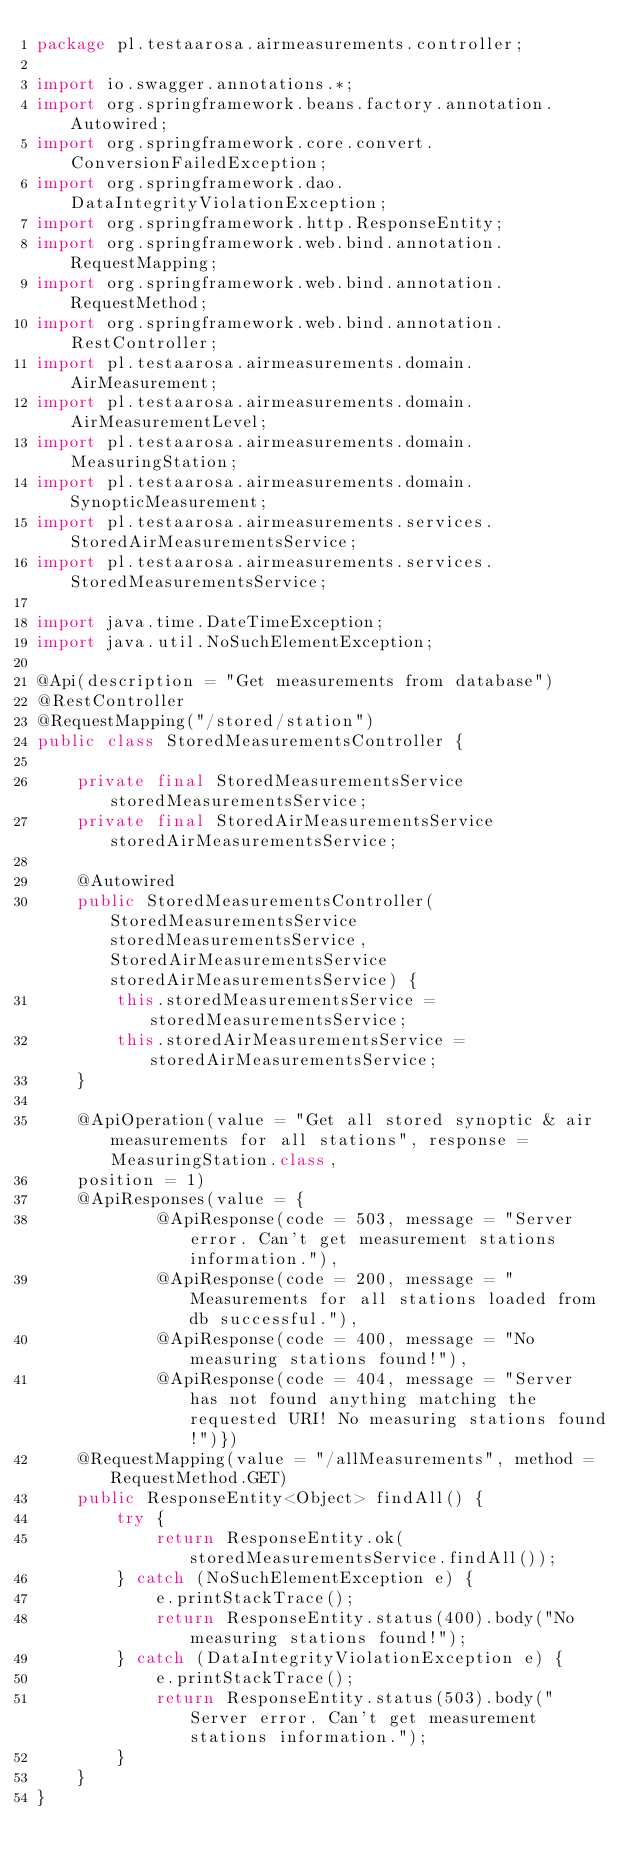<code> <loc_0><loc_0><loc_500><loc_500><_Java_>package pl.testaarosa.airmeasurements.controller;

import io.swagger.annotations.*;
import org.springframework.beans.factory.annotation.Autowired;
import org.springframework.core.convert.ConversionFailedException;
import org.springframework.dao.DataIntegrityViolationException;
import org.springframework.http.ResponseEntity;
import org.springframework.web.bind.annotation.RequestMapping;
import org.springframework.web.bind.annotation.RequestMethod;
import org.springframework.web.bind.annotation.RestController;
import pl.testaarosa.airmeasurements.domain.AirMeasurement;
import pl.testaarosa.airmeasurements.domain.AirMeasurementLevel;
import pl.testaarosa.airmeasurements.domain.MeasuringStation;
import pl.testaarosa.airmeasurements.domain.SynopticMeasurement;
import pl.testaarosa.airmeasurements.services.StoredAirMeasurementsService;
import pl.testaarosa.airmeasurements.services.StoredMeasurementsService;

import java.time.DateTimeException;
import java.util.NoSuchElementException;

@Api(description = "Get measurements from database")
@RestController
@RequestMapping("/stored/station")
public class StoredMeasurementsController {

    private final StoredMeasurementsService storedMeasurementsService;
    private final StoredAirMeasurementsService storedAirMeasurementsService;

    @Autowired
    public StoredMeasurementsController(StoredMeasurementsService storedMeasurementsService, StoredAirMeasurementsService storedAirMeasurementsService) {
        this.storedMeasurementsService = storedMeasurementsService;
        this.storedAirMeasurementsService = storedAirMeasurementsService;
    }

    @ApiOperation(value = "Get all stored synoptic & air measurements for all stations", response = MeasuringStation.class,
    position = 1)
    @ApiResponses(value = {
            @ApiResponse(code = 503, message = "Server error. Can't get measurement stations information."),
            @ApiResponse(code = 200, message = "Measurements for all stations loaded from db successful."),
            @ApiResponse(code = 400, message = "No measuring stations found!"),
            @ApiResponse(code = 404, message = "Server has not found anything matching the requested URI! No measuring stations found!")})
    @RequestMapping(value = "/allMeasurements", method = RequestMethod.GET)
    public ResponseEntity<Object> findAll() {
        try {
            return ResponseEntity.ok(storedMeasurementsService.findAll());
        } catch (NoSuchElementException e) {
            e.printStackTrace();
            return ResponseEntity.status(400).body("No measuring stations found!");
        } catch (DataIntegrityViolationException e) {
            e.printStackTrace();
            return ResponseEntity.status(503).body("Server error. Can't get measurement stations information.");
        }
    }
}
</code> 